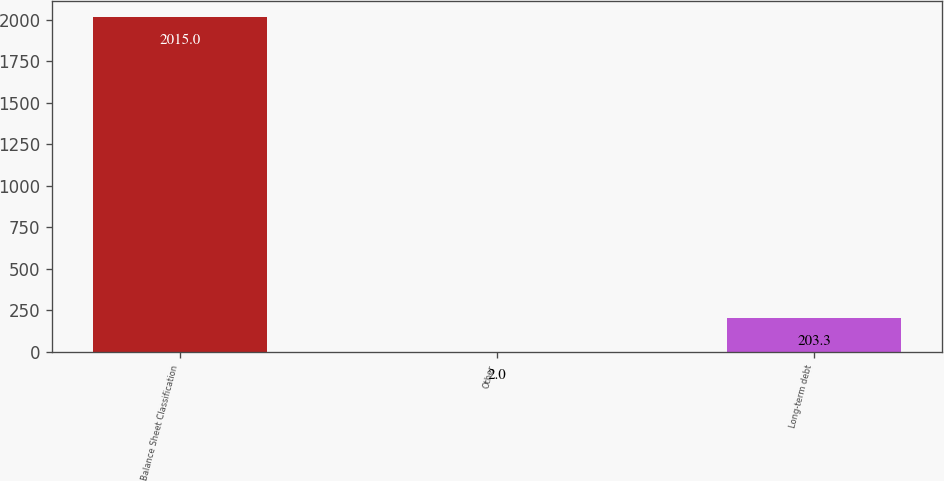<chart> <loc_0><loc_0><loc_500><loc_500><bar_chart><fcel>Balance Sheet Classification<fcel>Other<fcel>Long-term debt<nl><fcel>2015<fcel>2<fcel>203.3<nl></chart> 